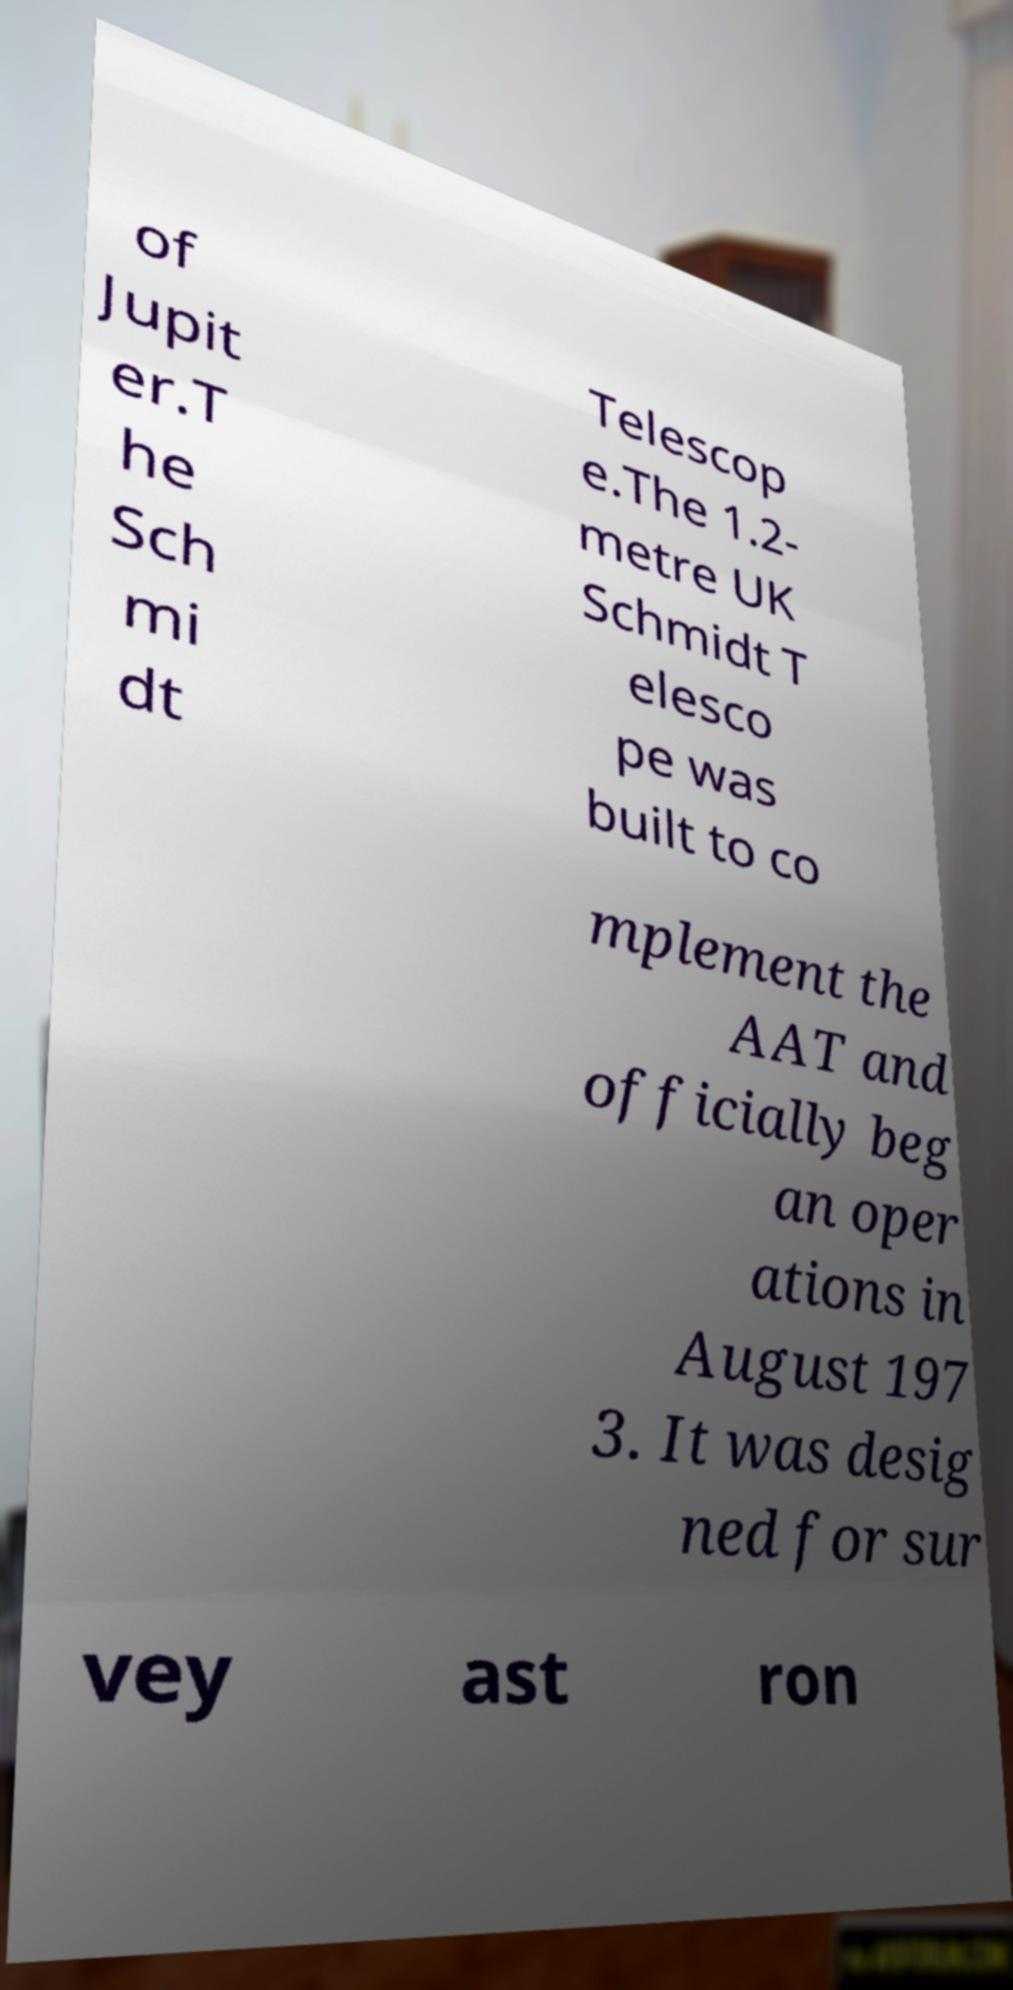Please read and relay the text visible in this image. What does it say? of Jupit er.T he Sch mi dt Telescop e.The 1.2- metre UK Schmidt T elesco pe was built to co mplement the AAT and officially beg an oper ations in August 197 3. It was desig ned for sur vey ast ron 